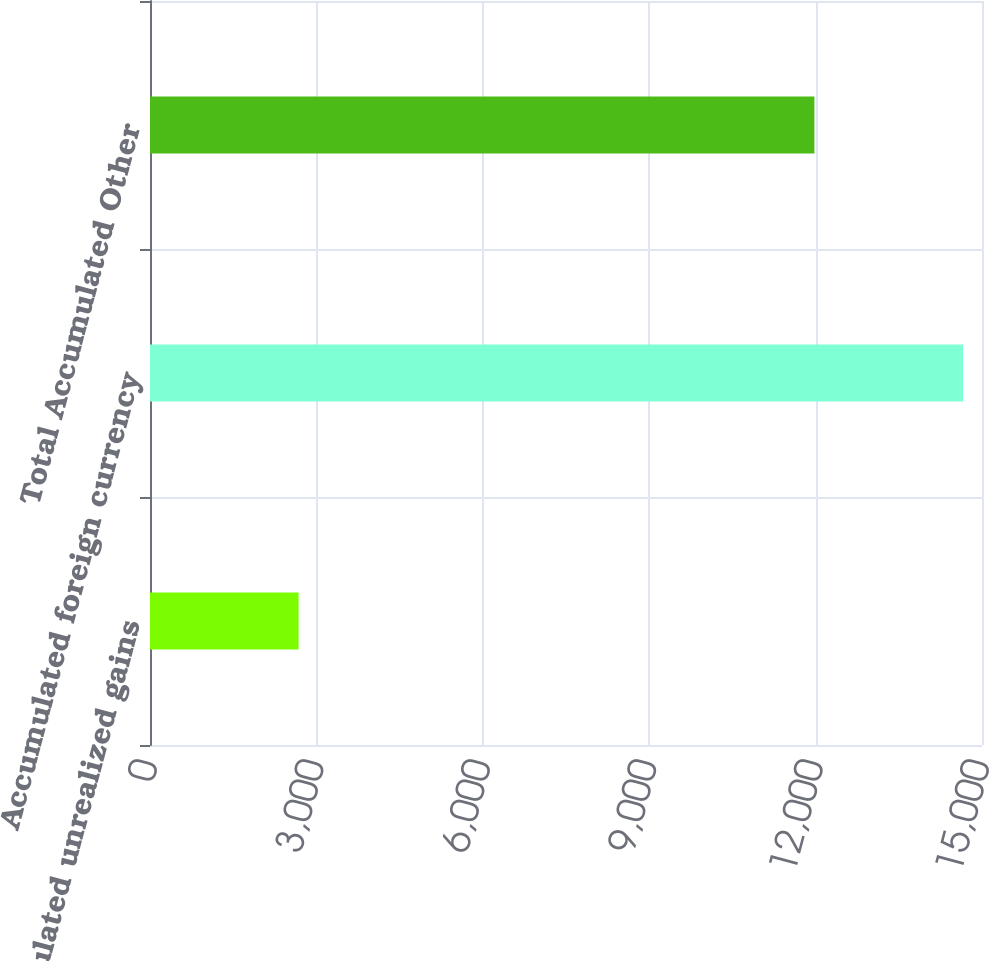<chart> <loc_0><loc_0><loc_500><loc_500><bar_chart><fcel>Accumulated unrealized gains<fcel>Accumulated foreign currency<fcel>Total Accumulated Other<nl><fcel>2679<fcel>14658<fcel>11979<nl></chart> 